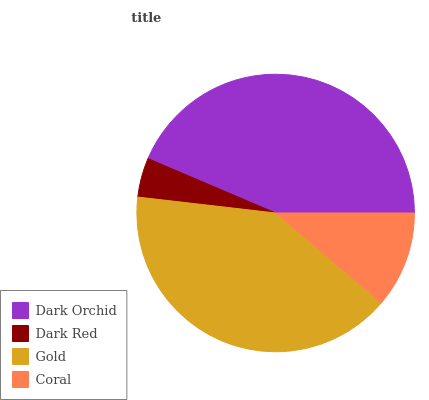Is Dark Red the minimum?
Answer yes or no. Yes. Is Dark Orchid the maximum?
Answer yes or no. Yes. Is Gold the minimum?
Answer yes or no. No. Is Gold the maximum?
Answer yes or no. No. Is Gold greater than Dark Red?
Answer yes or no. Yes. Is Dark Red less than Gold?
Answer yes or no. Yes. Is Dark Red greater than Gold?
Answer yes or no. No. Is Gold less than Dark Red?
Answer yes or no. No. Is Gold the high median?
Answer yes or no. Yes. Is Coral the low median?
Answer yes or no. Yes. Is Dark Orchid the high median?
Answer yes or no. No. Is Dark Orchid the low median?
Answer yes or no. No. 